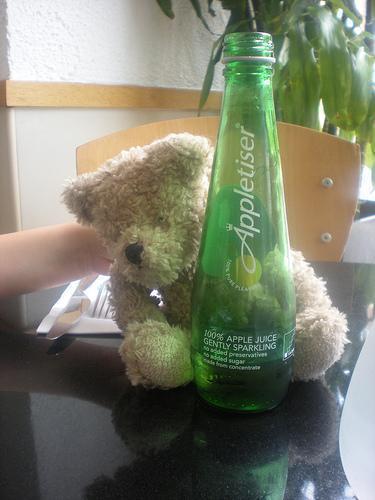How many letters are in the brand name on the bottle?
Give a very brief answer. 10. 